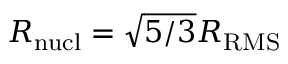Convert formula to latex. <formula><loc_0><loc_0><loc_500><loc_500>R _ { n u c l } = \sqrt { 5 / 3 } R _ { R M S }</formula> 